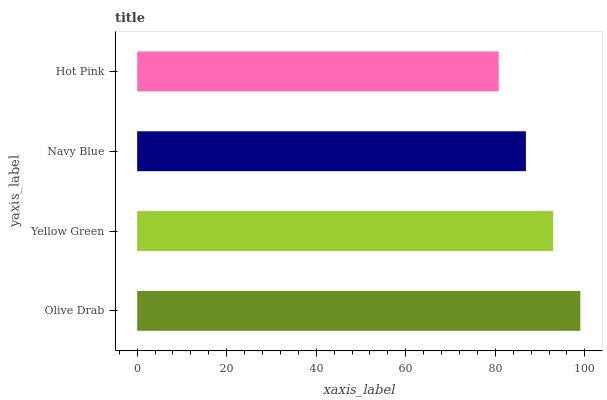Is Hot Pink the minimum?
Answer yes or no. Yes. Is Olive Drab the maximum?
Answer yes or no. Yes. Is Yellow Green the minimum?
Answer yes or no. No. Is Yellow Green the maximum?
Answer yes or no. No. Is Olive Drab greater than Yellow Green?
Answer yes or no. Yes. Is Yellow Green less than Olive Drab?
Answer yes or no. Yes. Is Yellow Green greater than Olive Drab?
Answer yes or no. No. Is Olive Drab less than Yellow Green?
Answer yes or no. No. Is Yellow Green the high median?
Answer yes or no. Yes. Is Navy Blue the low median?
Answer yes or no. Yes. Is Hot Pink the high median?
Answer yes or no. No. Is Hot Pink the low median?
Answer yes or no. No. 